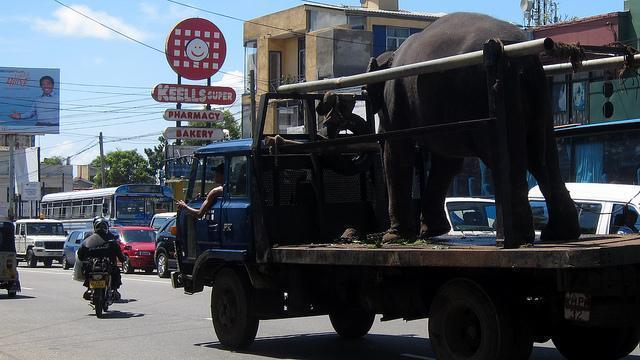How many cars can be seen?
Give a very brief answer. 2. How many trucks can be seen?
Give a very brief answer. 2. 